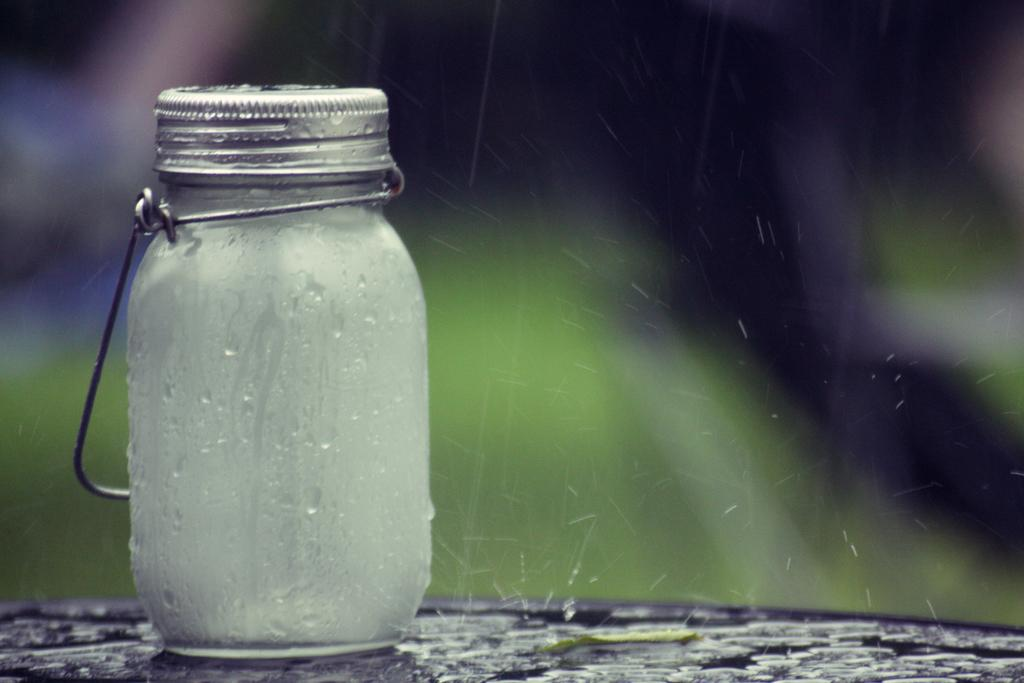What object is present on the ground in the image? There is a jar on the ground in the image. What feature does the jar have? The jar has a lid on it. What title is given to the clouds in the image? There are no clouds present in the image, so there is no title given to any clouds. 